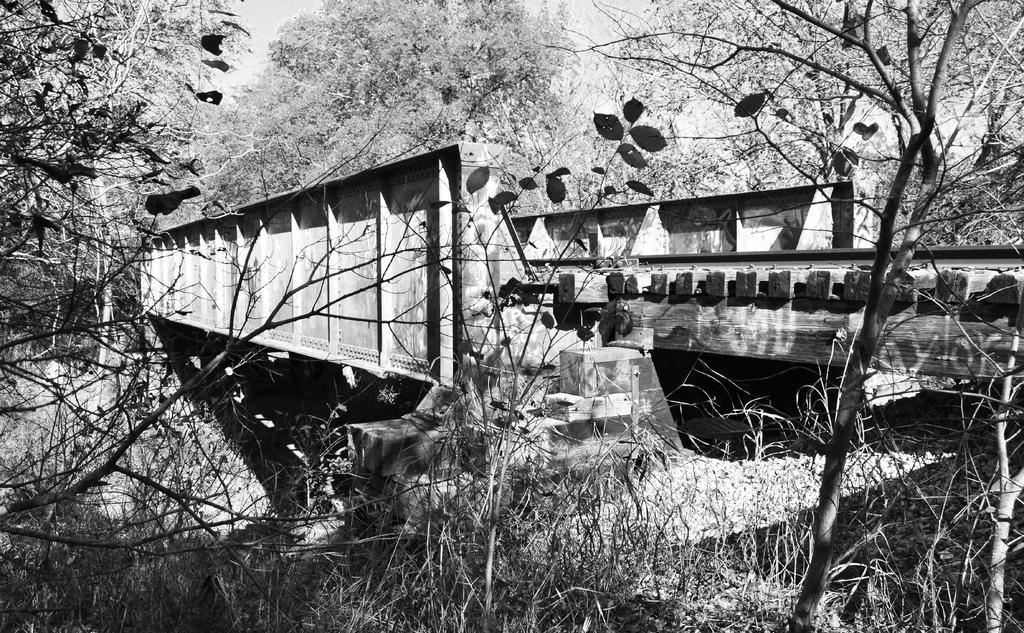Please provide a concise description of this image. In this picture I can see the railway track on the bridge. At the bottom I can see dry grass and leaves near to the wall. In the background I can see the forest. In the top left there is a sky and trees. 